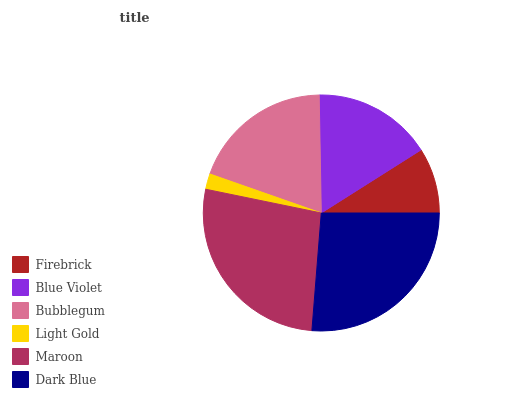Is Light Gold the minimum?
Answer yes or no. Yes. Is Maroon the maximum?
Answer yes or no. Yes. Is Blue Violet the minimum?
Answer yes or no. No. Is Blue Violet the maximum?
Answer yes or no. No. Is Blue Violet greater than Firebrick?
Answer yes or no. Yes. Is Firebrick less than Blue Violet?
Answer yes or no. Yes. Is Firebrick greater than Blue Violet?
Answer yes or no. No. Is Blue Violet less than Firebrick?
Answer yes or no. No. Is Bubblegum the high median?
Answer yes or no. Yes. Is Blue Violet the low median?
Answer yes or no. Yes. Is Maroon the high median?
Answer yes or no. No. Is Light Gold the low median?
Answer yes or no. No. 